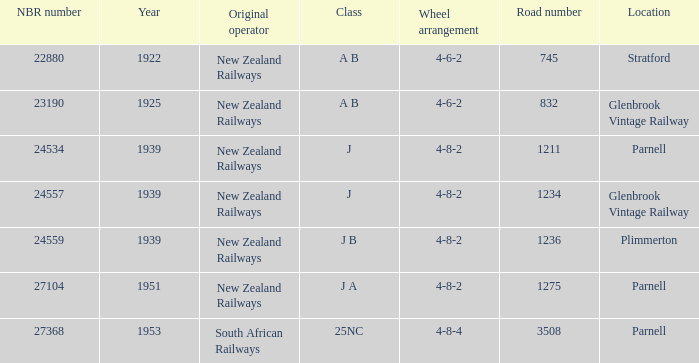Which class starts after 1939 and has a road number smaller than 3508? J A. 